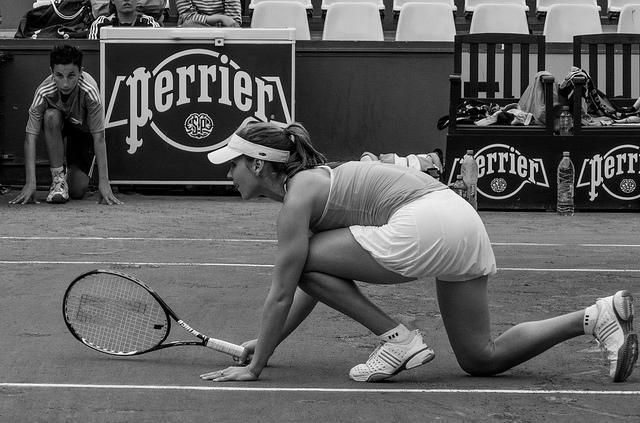How many chairs are there?
Give a very brief answer. 4. How many people are visible?
Give a very brief answer. 3. How many sheep are there?
Give a very brief answer. 0. 